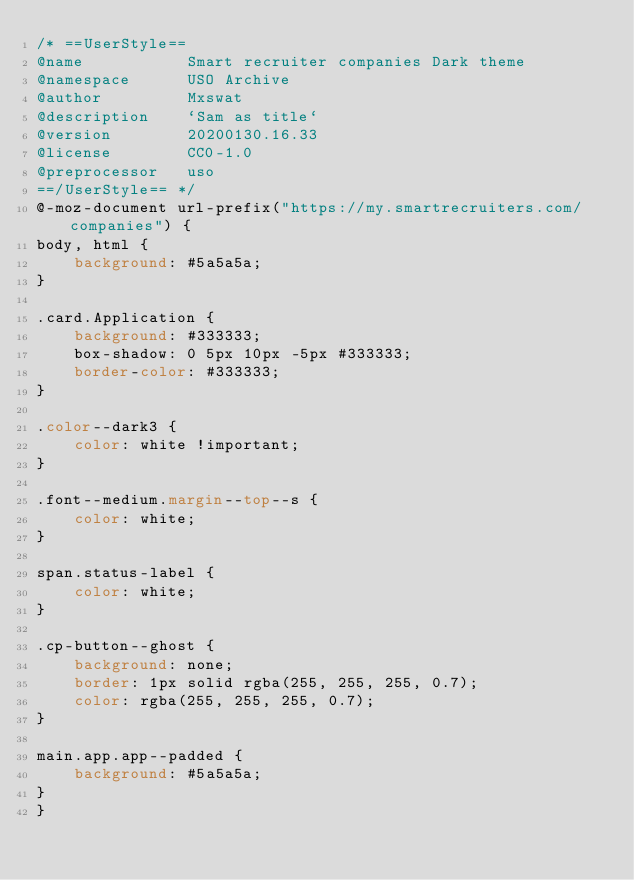Convert code to text. <code><loc_0><loc_0><loc_500><loc_500><_CSS_>/* ==UserStyle==
@name           Smart recruiter companies Dark theme
@namespace      USO Archive
@author         Mxswat
@description    `Sam as title`
@version        20200130.16.33
@license        CC0-1.0
@preprocessor   uso
==/UserStyle== */
@-moz-document url-prefix("https://my.smartrecruiters.com/companies") {
body, html {
    background: #5a5a5a;
}

.card.Application {
    background: #333333;
    box-shadow: 0 5px 10px -5px #333333;
    border-color: #333333;
}

.color--dark3 {
    color: white !important;
}

.font--medium.margin--top--s {
    color: white;
}

span.status-label {
    color: white;
}

.cp-button--ghost {
    background: none;
    border: 1px solid rgba(255, 255, 255, 0.7);
    color: rgba(255, 255, 255, 0.7);
}

main.app.app--padded {
    background: #5a5a5a;
}
}</code> 